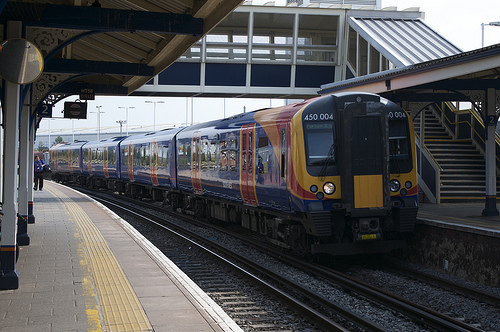Can you describe the features seen on the train present in the bounding box [0.47, 0.41, 0.51, 0.58]? The train section visible in the specified coordinates highlights the middle segment of a carriage, notably featuring a red door used by passengers to enter or exit the train. 